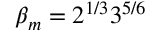<formula> <loc_0><loc_0><loc_500><loc_500>\beta _ { m } = 2 ^ { 1 / 3 } 3 ^ { 5 / 6 }</formula> 